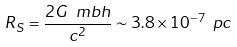<formula> <loc_0><loc_0><loc_500><loc_500>R _ { S } = \frac { 2 G \ m b h } { c ^ { 2 } } \sim 3 . 8 \times 1 0 ^ { - 7 } \ p c</formula> 